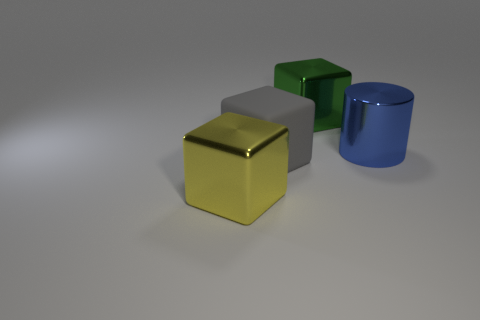Subtract all big metal blocks. How many blocks are left? 1 Add 4 big cyan balls. How many objects exist? 8 Subtract all green blocks. How many blocks are left? 2 Subtract 0 blue cubes. How many objects are left? 4 Subtract all cylinders. How many objects are left? 3 Subtract 1 cubes. How many cubes are left? 2 Subtract all gray cubes. Subtract all red spheres. How many cubes are left? 2 Subtract all brown cylinders. How many blue cubes are left? 0 Subtract all tiny cyan cylinders. Subtract all large blocks. How many objects are left? 1 Add 3 big things. How many big things are left? 7 